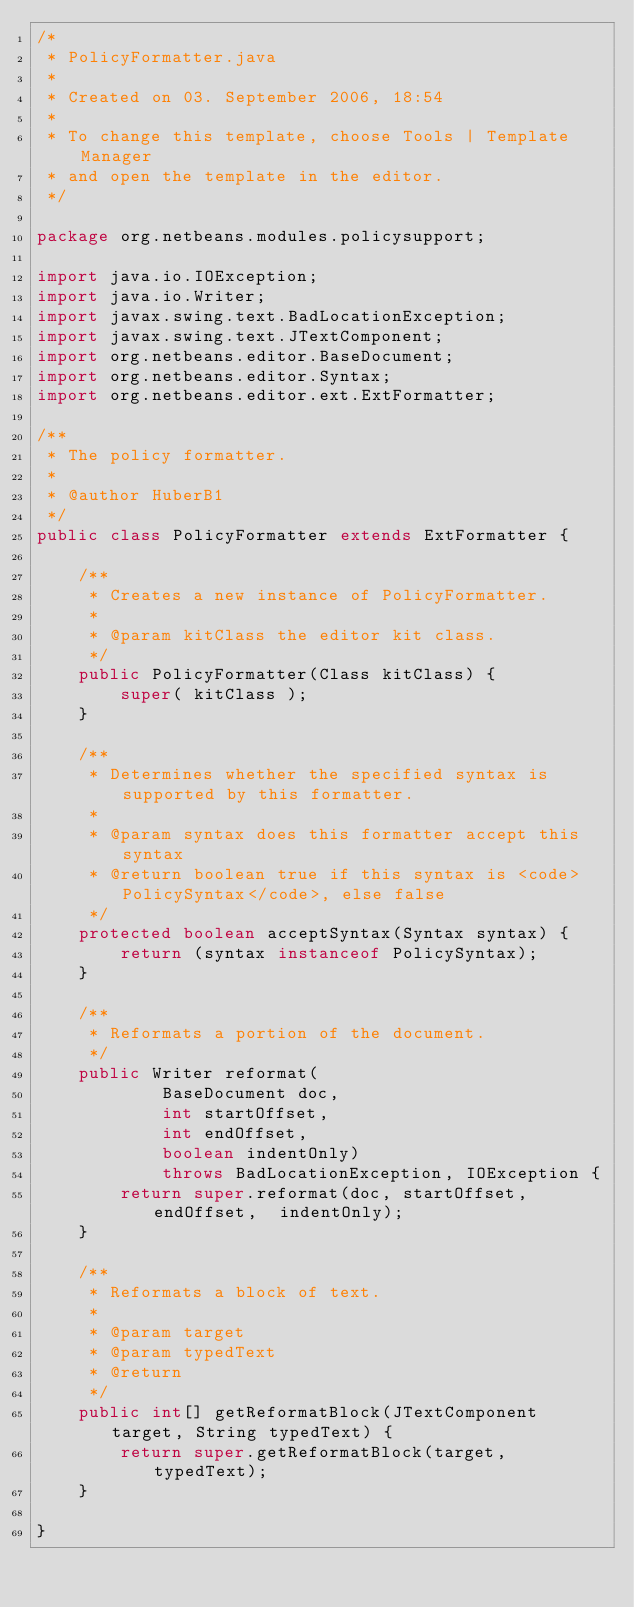<code> <loc_0><loc_0><loc_500><loc_500><_Java_>/*
 * PolicyFormatter.java
 *
 * Created on 03. September 2006, 18:54
 *
 * To change this template, choose Tools | Template Manager
 * and open the template in the editor.
 */

package org.netbeans.modules.policysupport;

import java.io.IOException;
import java.io.Writer;
import javax.swing.text.BadLocationException;
import javax.swing.text.JTextComponent;
import org.netbeans.editor.BaseDocument;
import org.netbeans.editor.Syntax;
import org.netbeans.editor.ext.ExtFormatter;

/**
 * The policy formatter.
 *
 * @author HuberB1
 */
public class PolicyFormatter extends ExtFormatter {
    
    /** 
     * Creates a new instance of PolicyFormatter.
     *
     * @param kitClass the editor kit class.
     */
    public PolicyFormatter(Class kitClass) {
        super( kitClass );
    }
    
    /**
     * Determines whether the specified syntax is supported by this formatter.
     *
     * @param syntax does this formatter accept this syntax
     * @return boolean true if this syntax is <code>PolicySyntax</code>, else false
     */
    protected boolean acceptSyntax(Syntax syntax) {
        return (syntax instanceof PolicySyntax);
    }
    
    /**
     * Reformats a portion of the document.
     */
    public Writer reformat(
            BaseDocument doc,
            int startOffset,
            int endOffset,
            boolean indentOnly)
            throws BadLocationException, IOException {
        return super.reformat(doc, startOffset, endOffset,  indentOnly);
    }
    
    /**
     * Reformats a block of text.
     *
     * @param target 
     * @param typedText 
     * @return 
     */
    public int[] getReformatBlock(JTextComponent target, String typedText) {
        return super.getReformatBlock(target, typedText);
    }
    
}
</code> 